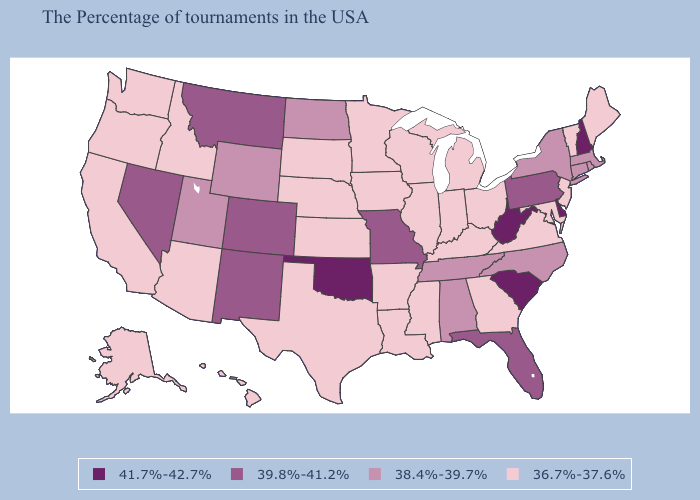Does Iowa have the lowest value in the USA?
Short answer required. Yes. Among the states that border Kentucky , does Missouri have the highest value?
Write a very short answer. No. What is the value of Tennessee?
Give a very brief answer. 38.4%-39.7%. Name the states that have a value in the range 38.4%-39.7%?
Be succinct. Massachusetts, Rhode Island, Connecticut, New York, North Carolina, Alabama, Tennessee, North Dakota, Wyoming, Utah. What is the highest value in the USA?
Answer briefly. 41.7%-42.7%. What is the lowest value in the MidWest?
Be succinct. 36.7%-37.6%. Does the first symbol in the legend represent the smallest category?
Write a very short answer. No. Which states hav the highest value in the Northeast?
Be succinct. New Hampshire. Name the states that have a value in the range 36.7%-37.6%?
Write a very short answer. Maine, Vermont, New Jersey, Maryland, Virginia, Ohio, Georgia, Michigan, Kentucky, Indiana, Wisconsin, Illinois, Mississippi, Louisiana, Arkansas, Minnesota, Iowa, Kansas, Nebraska, Texas, South Dakota, Arizona, Idaho, California, Washington, Oregon, Alaska, Hawaii. Does South Carolina have the highest value in the USA?
Answer briefly. Yes. Among the states that border Ohio , does West Virginia have the lowest value?
Answer briefly. No. Is the legend a continuous bar?
Write a very short answer. No. Does New Hampshire have the highest value in the Northeast?
Write a very short answer. Yes. Among the states that border Colorado , does Oklahoma have the highest value?
Answer briefly. Yes. Does Wyoming have the same value as Arizona?
Quick response, please. No. 